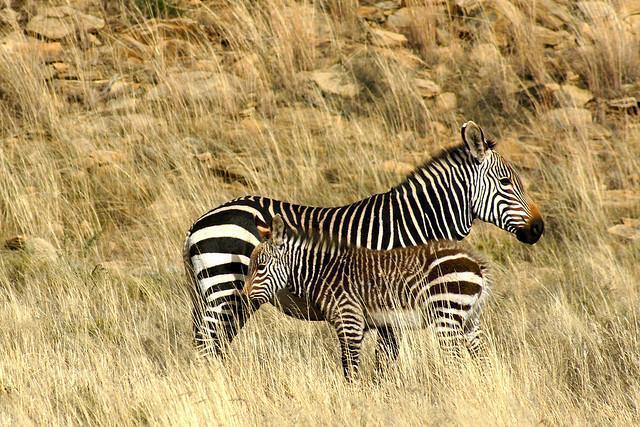How many zebras are there?
Give a very brief answer. 2. How many people are carrying surf boards?
Give a very brief answer. 0. 